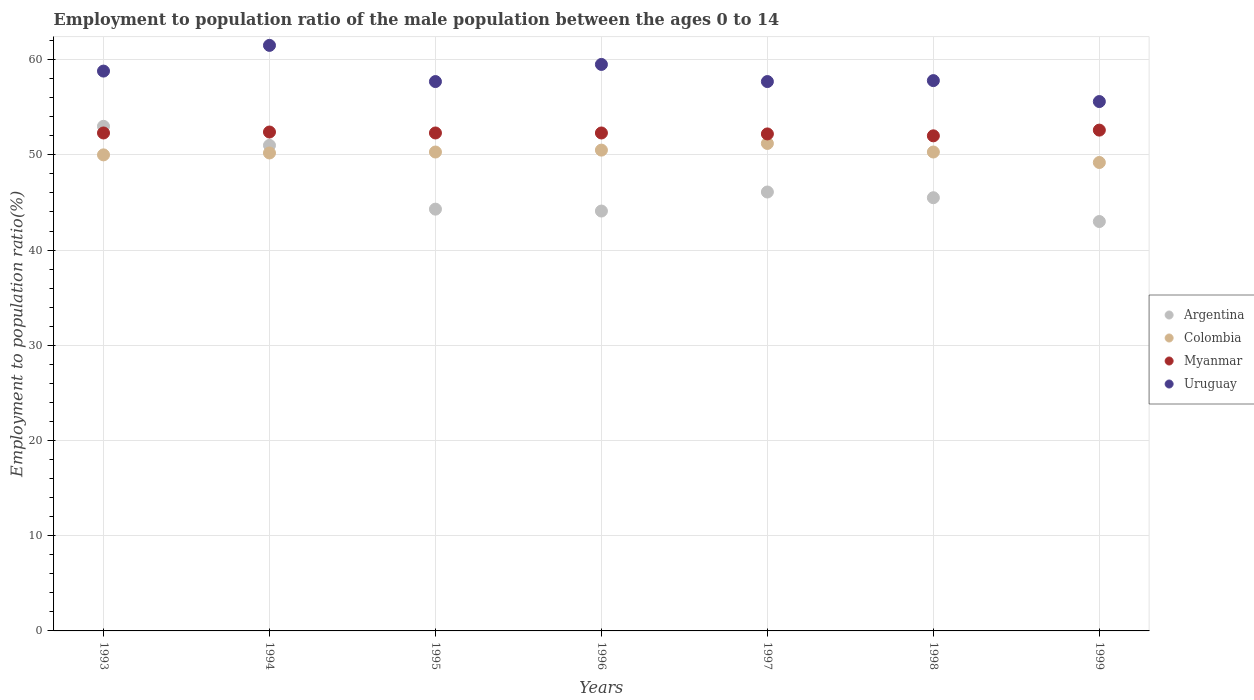What is the employment to population ratio in Colombia in 1996?
Your answer should be very brief. 50.5. Across all years, what is the maximum employment to population ratio in Colombia?
Give a very brief answer. 51.2. Across all years, what is the minimum employment to population ratio in Uruguay?
Ensure brevity in your answer.  55.6. In which year was the employment to population ratio in Uruguay maximum?
Provide a succinct answer. 1994. In which year was the employment to population ratio in Myanmar minimum?
Your answer should be very brief. 1998. What is the total employment to population ratio in Myanmar in the graph?
Your answer should be very brief. 366.1. What is the difference between the employment to population ratio in Argentina in 1996 and that in 1999?
Provide a short and direct response. 1.1. What is the difference between the employment to population ratio in Colombia in 1993 and the employment to population ratio in Argentina in 1997?
Your answer should be compact. 3.9. What is the average employment to population ratio in Argentina per year?
Offer a very short reply. 46.71. In the year 1998, what is the difference between the employment to population ratio in Argentina and employment to population ratio in Myanmar?
Provide a short and direct response. -6.5. What is the ratio of the employment to population ratio in Argentina in 1993 to that in 1997?
Your response must be concise. 1.15. What is the difference between the highest and the second highest employment to population ratio in Colombia?
Make the answer very short. 0.7. What is the difference between the highest and the lowest employment to population ratio in Uruguay?
Ensure brevity in your answer.  5.9. In how many years, is the employment to population ratio in Uruguay greater than the average employment to population ratio in Uruguay taken over all years?
Ensure brevity in your answer.  3. Is the sum of the employment to population ratio in Uruguay in 1994 and 1999 greater than the maximum employment to population ratio in Colombia across all years?
Offer a very short reply. Yes. Is it the case that in every year, the sum of the employment to population ratio in Myanmar and employment to population ratio in Colombia  is greater than the sum of employment to population ratio in Argentina and employment to population ratio in Uruguay?
Provide a short and direct response. No. Is the employment to population ratio in Uruguay strictly less than the employment to population ratio in Myanmar over the years?
Give a very brief answer. No. How many dotlines are there?
Your answer should be very brief. 4. How many years are there in the graph?
Give a very brief answer. 7. Are the values on the major ticks of Y-axis written in scientific E-notation?
Keep it short and to the point. No. Does the graph contain any zero values?
Your response must be concise. No. Does the graph contain grids?
Make the answer very short. Yes. How many legend labels are there?
Your response must be concise. 4. How are the legend labels stacked?
Make the answer very short. Vertical. What is the title of the graph?
Your response must be concise. Employment to population ratio of the male population between the ages 0 to 14. What is the label or title of the X-axis?
Your answer should be very brief. Years. What is the Employment to population ratio(%) in Myanmar in 1993?
Your answer should be very brief. 52.3. What is the Employment to population ratio(%) of Uruguay in 1993?
Make the answer very short. 58.8. What is the Employment to population ratio(%) in Argentina in 1994?
Your answer should be compact. 51. What is the Employment to population ratio(%) of Colombia in 1994?
Ensure brevity in your answer.  50.2. What is the Employment to population ratio(%) of Myanmar in 1994?
Offer a terse response. 52.4. What is the Employment to population ratio(%) of Uruguay in 1994?
Offer a terse response. 61.5. What is the Employment to population ratio(%) of Argentina in 1995?
Make the answer very short. 44.3. What is the Employment to population ratio(%) of Colombia in 1995?
Your answer should be compact. 50.3. What is the Employment to population ratio(%) in Myanmar in 1995?
Give a very brief answer. 52.3. What is the Employment to population ratio(%) of Uruguay in 1995?
Provide a succinct answer. 57.7. What is the Employment to population ratio(%) in Argentina in 1996?
Provide a succinct answer. 44.1. What is the Employment to population ratio(%) of Colombia in 1996?
Provide a succinct answer. 50.5. What is the Employment to population ratio(%) in Myanmar in 1996?
Your answer should be very brief. 52.3. What is the Employment to population ratio(%) in Uruguay in 1996?
Your response must be concise. 59.5. What is the Employment to population ratio(%) in Argentina in 1997?
Your answer should be compact. 46.1. What is the Employment to population ratio(%) in Colombia in 1997?
Provide a short and direct response. 51.2. What is the Employment to population ratio(%) of Myanmar in 1997?
Your response must be concise. 52.2. What is the Employment to population ratio(%) in Uruguay in 1997?
Ensure brevity in your answer.  57.7. What is the Employment to population ratio(%) of Argentina in 1998?
Your answer should be very brief. 45.5. What is the Employment to population ratio(%) of Colombia in 1998?
Offer a terse response. 50.3. What is the Employment to population ratio(%) of Myanmar in 1998?
Provide a succinct answer. 52. What is the Employment to population ratio(%) of Uruguay in 1998?
Your answer should be compact. 57.8. What is the Employment to population ratio(%) in Colombia in 1999?
Make the answer very short. 49.2. What is the Employment to population ratio(%) in Myanmar in 1999?
Offer a terse response. 52.6. What is the Employment to population ratio(%) of Uruguay in 1999?
Provide a short and direct response. 55.6. Across all years, what is the maximum Employment to population ratio(%) of Argentina?
Provide a short and direct response. 53. Across all years, what is the maximum Employment to population ratio(%) in Colombia?
Ensure brevity in your answer.  51.2. Across all years, what is the maximum Employment to population ratio(%) of Myanmar?
Your response must be concise. 52.6. Across all years, what is the maximum Employment to population ratio(%) of Uruguay?
Your response must be concise. 61.5. Across all years, what is the minimum Employment to population ratio(%) in Colombia?
Give a very brief answer. 49.2. Across all years, what is the minimum Employment to population ratio(%) of Uruguay?
Provide a succinct answer. 55.6. What is the total Employment to population ratio(%) in Argentina in the graph?
Provide a succinct answer. 327. What is the total Employment to population ratio(%) of Colombia in the graph?
Make the answer very short. 351.7. What is the total Employment to population ratio(%) of Myanmar in the graph?
Offer a terse response. 366.1. What is the total Employment to population ratio(%) of Uruguay in the graph?
Give a very brief answer. 408.6. What is the difference between the Employment to population ratio(%) in Argentina in 1993 and that in 1994?
Give a very brief answer. 2. What is the difference between the Employment to population ratio(%) of Colombia in 1993 and that in 1994?
Provide a succinct answer. -0.2. What is the difference between the Employment to population ratio(%) of Uruguay in 1993 and that in 1994?
Ensure brevity in your answer.  -2.7. What is the difference between the Employment to population ratio(%) in Colombia in 1993 and that in 1995?
Your answer should be very brief. -0.3. What is the difference between the Employment to population ratio(%) in Colombia in 1993 and that in 1996?
Keep it short and to the point. -0.5. What is the difference between the Employment to population ratio(%) in Myanmar in 1993 and that in 1996?
Offer a terse response. 0. What is the difference between the Employment to population ratio(%) in Argentina in 1993 and that in 1997?
Your answer should be compact. 6.9. What is the difference between the Employment to population ratio(%) in Colombia in 1993 and that in 1997?
Offer a terse response. -1.2. What is the difference between the Employment to population ratio(%) in Colombia in 1993 and that in 1998?
Offer a very short reply. -0.3. What is the difference between the Employment to population ratio(%) of Myanmar in 1993 and that in 1998?
Make the answer very short. 0.3. What is the difference between the Employment to population ratio(%) in Myanmar in 1993 and that in 1999?
Ensure brevity in your answer.  -0.3. What is the difference between the Employment to population ratio(%) in Uruguay in 1993 and that in 1999?
Your answer should be very brief. 3.2. What is the difference between the Employment to population ratio(%) of Argentina in 1994 and that in 1996?
Provide a short and direct response. 6.9. What is the difference between the Employment to population ratio(%) of Myanmar in 1994 and that in 1996?
Ensure brevity in your answer.  0.1. What is the difference between the Employment to population ratio(%) of Argentina in 1994 and that in 1997?
Your answer should be very brief. 4.9. What is the difference between the Employment to population ratio(%) in Colombia in 1994 and that in 1997?
Offer a terse response. -1. What is the difference between the Employment to population ratio(%) of Myanmar in 1994 and that in 1997?
Give a very brief answer. 0.2. What is the difference between the Employment to population ratio(%) in Argentina in 1994 and that in 1998?
Your answer should be very brief. 5.5. What is the difference between the Employment to population ratio(%) of Colombia in 1994 and that in 1998?
Make the answer very short. -0.1. What is the difference between the Employment to population ratio(%) of Myanmar in 1994 and that in 1998?
Ensure brevity in your answer.  0.4. What is the difference between the Employment to population ratio(%) of Uruguay in 1994 and that in 1998?
Provide a short and direct response. 3.7. What is the difference between the Employment to population ratio(%) in Colombia in 1995 and that in 1996?
Your response must be concise. -0.2. What is the difference between the Employment to population ratio(%) in Uruguay in 1995 and that in 1996?
Offer a very short reply. -1.8. What is the difference between the Employment to population ratio(%) in Argentina in 1995 and that in 1997?
Provide a succinct answer. -1.8. What is the difference between the Employment to population ratio(%) of Myanmar in 1995 and that in 1997?
Ensure brevity in your answer.  0.1. What is the difference between the Employment to population ratio(%) in Colombia in 1995 and that in 1998?
Your answer should be compact. 0. What is the difference between the Employment to population ratio(%) of Myanmar in 1995 and that in 1999?
Your answer should be very brief. -0.3. What is the difference between the Employment to population ratio(%) in Colombia in 1996 and that in 1997?
Provide a succinct answer. -0.7. What is the difference between the Employment to population ratio(%) in Uruguay in 1996 and that in 1997?
Keep it short and to the point. 1.8. What is the difference between the Employment to population ratio(%) in Colombia in 1996 and that in 1998?
Make the answer very short. 0.2. What is the difference between the Employment to population ratio(%) in Argentina in 1996 and that in 1999?
Your answer should be compact. 1.1. What is the difference between the Employment to population ratio(%) of Myanmar in 1996 and that in 1999?
Give a very brief answer. -0.3. What is the difference between the Employment to population ratio(%) of Uruguay in 1996 and that in 1999?
Provide a short and direct response. 3.9. What is the difference between the Employment to population ratio(%) of Colombia in 1997 and that in 1998?
Your answer should be very brief. 0.9. What is the difference between the Employment to population ratio(%) in Uruguay in 1997 and that in 1999?
Provide a short and direct response. 2.1. What is the difference between the Employment to population ratio(%) of Colombia in 1998 and that in 1999?
Your response must be concise. 1.1. What is the difference between the Employment to population ratio(%) in Argentina in 1993 and the Employment to population ratio(%) in Colombia in 1994?
Your answer should be compact. 2.8. What is the difference between the Employment to population ratio(%) in Argentina in 1993 and the Employment to population ratio(%) in Myanmar in 1994?
Your answer should be very brief. 0.6. What is the difference between the Employment to population ratio(%) of Argentina in 1993 and the Employment to population ratio(%) of Uruguay in 1994?
Provide a succinct answer. -8.5. What is the difference between the Employment to population ratio(%) in Argentina in 1993 and the Employment to population ratio(%) in Colombia in 1995?
Your answer should be very brief. 2.7. What is the difference between the Employment to population ratio(%) in Argentina in 1993 and the Employment to population ratio(%) in Myanmar in 1995?
Your response must be concise. 0.7. What is the difference between the Employment to population ratio(%) of Colombia in 1993 and the Employment to population ratio(%) of Uruguay in 1995?
Ensure brevity in your answer.  -7.7. What is the difference between the Employment to population ratio(%) of Myanmar in 1993 and the Employment to population ratio(%) of Uruguay in 1995?
Your answer should be compact. -5.4. What is the difference between the Employment to population ratio(%) of Argentina in 1993 and the Employment to population ratio(%) of Myanmar in 1996?
Your answer should be compact. 0.7. What is the difference between the Employment to population ratio(%) in Argentina in 1993 and the Employment to population ratio(%) in Uruguay in 1996?
Offer a very short reply. -6.5. What is the difference between the Employment to population ratio(%) of Colombia in 1993 and the Employment to population ratio(%) of Uruguay in 1996?
Your response must be concise. -9.5. What is the difference between the Employment to population ratio(%) of Argentina in 1993 and the Employment to population ratio(%) of Colombia in 1997?
Your response must be concise. 1.8. What is the difference between the Employment to population ratio(%) of Argentina in 1993 and the Employment to population ratio(%) of Uruguay in 1997?
Provide a succinct answer. -4.7. What is the difference between the Employment to population ratio(%) of Colombia in 1993 and the Employment to population ratio(%) of Myanmar in 1997?
Provide a succinct answer. -2.2. What is the difference between the Employment to population ratio(%) in Colombia in 1993 and the Employment to population ratio(%) in Uruguay in 1997?
Ensure brevity in your answer.  -7.7. What is the difference between the Employment to population ratio(%) in Argentina in 1993 and the Employment to population ratio(%) in Colombia in 1998?
Provide a short and direct response. 2.7. What is the difference between the Employment to population ratio(%) in Argentina in 1993 and the Employment to population ratio(%) in Myanmar in 1998?
Make the answer very short. 1. What is the difference between the Employment to population ratio(%) in Argentina in 1993 and the Employment to population ratio(%) in Uruguay in 1998?
Provide a succinct answer. -4.8. What is the difference between the Employment to population ratio(%) of Colombia in 1993 and the Employment to population ratio(%) of Uruguay in 1998?
Provide a succinct answer. -7.8. What is the difference between the Employment to population ratio(%) in Myanmar in 1993 and the Employment to population ratio(%) in Uruguay in 1998?
Your response must be concise. -5.5. What is the difference between the Employment to population ratio(%) of Argentina in 1993 and the Employment to population ratio(%) of Uruguay in 1999?
Provide a short and direct response. -2.6. What is the difference between the Employment to population ratio(%) in Argentina in 1994 and the Employment to population ratio(%) in Uruguay in 1995?
Offer a terse response. -6.7. What is the difference between the Employment to population ratio(%) of Colombia in 1994 and the Employment to population ratio(%) of Myanmar in 1995?
Ensure brevity in your answer.  -2.1. What is the difference between the Employment to population ratio(%) of Colombia in 1994 and the Employment to population ratio(%) of Myanmar in 1996?
Make the answer very short. -2.1. What is the difference between the Employment to population ratio(%) of Colombia in 1994 and the Employment to population ratio(%) of Uruguay in 1996?
Your answer should be compact. -9.3. What is the difference between the Employment to population ratio(%) of Myanmar in 1994 and the Employment to population ratio(%) of Uruguay in 1996?
Offer a terse response. -7.1. What is the difference between the Employment to population ratio(%) in Argentina in 1994 and the Employment to population ratio(%) in Colombia in 1997?
Give a very brief answer. -0.2. What is the difference between the Employment to population ratio(%) in Colombia in 1994 and the Employment to population ratio(%) in Myanmar in 1997?
Give a very brief answer. -2. What is the difference between the Employment to population ratio(%) in Colombia in 1994 and the Employment to population ratio(%) in Uruguay in 1997?
Offer a terse response. -7.5. What is the difference between the Employment to population ratio(%) of Myanmar in 1994 and the Employment to population ratio(%) of Uruguay in 1997?
Make the answer very short. -5.3. What is the difference between the Employment to population ratio(%) of Argentina in 1994 and the Employment to population ratio(%) of Colombia in 1998?
Your response must be concise. 0.7. What is the difference between the Employment to population ratio(%) of Argentina in 1994 and the Employment to population ratio(%) of Myanmar in 1998?
Provide a succinct answer. -1. What is the difference between the Employment to population ratio(%) in Colombia in 1994 and the Employment to population ratio(%) in Myanmar in 1998?
Give a very brief answer. -1.8. What is the difference between the Employment to population ratio(%) in Colombia in 1994 and the Employment to population ratio(%) in Uruguay in 1998?
Offer a very short reply. -7.6. What is the difference between the Employment to population ratio(%) in Myanmar in 1994 and the Employment to population ratio(%) in Uruguay in 1998?
Offer a very short reply. -5.4. What is the difference between the Employment to population ratio(%) of Argentina in 1994 and the Employment to population ratio(%) of Myanmar in 1999?
Your answer should be compact. -1.6. What is the difference between the Employment to population ratio(%) in Myanmar in 1994 and the Employment to population ratio(%) in Uruguay in 1999?
Offer a very short reply. -3.2. What is the difference between the Employment to population ratio(%) of Argentina in 1995 and the Employment to population ratio(%) of Uruguay in 1996?
Keep it short and to the point. -15.2. What is the difference between the Employment to population ratio(%) of Colombia in 1995 and the Employment to population ratio(%) of Myanmar in 1996?
Offer a terse response. -2. What is the difference between the Employment to population ratio(%) of Colombia in 1995 and the Employment to population ratio(%) of Uruguay in 1996?
Offer a very short reply. -9.2. What is the difference between the Employment to population ratio(%) of Myanmar in 1995 and the Employment to population ratio(%) of Uruguay in 1996?
Provide a succinct answer. -7.2. What is the difference between the Employment to population ratio(%) of Argentina in 1995 and the Employment to population ratio(%) of Uruguay in 1997?
Ensure brevity in your answer.  -13.4. What is the difference between the Employment to population ratio(%) in Colombia in 1995 and the Employment to population ratio(%) in Myanmar in 1997?
Offer a very short reply. -1.9. What is the difference between the Employment to population ratio(%) of Colombia in 1995 and the Employment to population ratio(%) of Uruguay in 1997?
Keep it short and to the point. -7.4. What is the difference between the Employment to population ratio(%) of Myanmar in 1995 and the Employment to population ratio(%) of Uruguay in 1997?
Your answer should be very brief. -5.4. What is the difference between the Employment to population ratio(%) in Argentina in 1995 and the Employment to population ratio(%) in Colombia in 1998?
Provide a short and direct response. -6. What is the difference between the Employment to population ratio(%) in Colombia in 1995 and the Employment to population ratio(%) in Myanmar in 1998?
Your answer should be compact. -1.7. What is the difference between the Employment to population ratio(%) of Colombia in 1995 and the Employment to population ratio(%) of Uruguay in 1998?
Offer a very short reply. -7.5. What is the difference between the Employment to population ratio(%) in Myanmar in 1995 and the Employment to population ratio(%) in Uruguay in 1998?
Provide a succinct answer. -5.5. What is the difference between the Employment to population ratio(%) in Argentina in 1995 and the Employment to population ratio(%) in Uruguay in 1999?
Offer a terse response. -11.3. What is the difference between the Employment to population ratio(%) of Colombia in 1995 and the Employment to population ratio(%) of Myanmar in 1999?
Ensure brevity in your answer.  -2.3. What is the difference between the Employment to population ratio(%) of Colombia in 1995 and the Employment to population ratio(%) of Uruguay in 1999?
Provide a succinct answer. -5.3. What is the difference between the Employment to population ratio(%) of Argentina in 1996 and the Employment to population ratio(%) of Colombia in 1997?
Your response must be concise. -7.1. What is the difference between the Employment to population ratio(%) of Argentina in 1996 and the Employment to population ratio(%) of Uruguay in 1997?
Your answer should be compact. -13.6. What is the difference between the Employment to population ratio(%) in Colombia in 1996 and the Employment to population ratio(%) in Myanmar in 1997?
Your answer should be very brief. -1.7. What is the difference between the Employment to population ratio(%) in Colombia in 1996 and the Employment to population ratio(%) in Uruguay in 1997?
Offer a very short reply. -7.2. What is the difference between the Employment to population ratio(%) of Myanmar in 1996 and the Employment to population ratio(%) of Uruguay in 1997?
Your response must be concise. -5.4. What is the difference between the Employment to population ratio(%) in Argentina in 1996 and the Employment to population ratio(%) in Myanmar in 1998?
Keep it short and to the point. -7.9. What is the difference between the Employment to population ratio(%) of Argentina in 1996 and the Employment to population ratio(%) of Uruguay in 1998?
Your response must be concise. -13.7. What is the difference between the Employment to population ratio(%) of Colombia in 1996 and the Employment to population ratio(%) of Uruguay in 1998?
Your response must be concise. -7.3. What is the difference between the Employment to population ratio(%) in Myanmar in 1996 and the Employment to population ratio(%) in Uruguay in 1998?
Your response must be concise. -5.5. What is the difference between the Employment to population ratio(%) of Argentina in 1996 and the Employment to population ratio(%) of Colombia in 1999?
Offer a terse response. -5.1. What is the difference between the Employment to population ratio(%) of Argentina in 1996 and the Employment to population ratio(%) of Myanmar in 1999?
Provide a short and direct response. -8.5. What is the difference between the Employment to population ratio(%) in Colombia in 1996 and the Employment to population ratio(%) in Uruguay in 1999?
Make the answer very short. -5.1. What is the difference between the Employment to population ratio(%) of Argentina in 1997 and the Employment to population ratio(%) of Colombia in 1998?
Keep it short and to the point. -4.2. What is the difference between the Employment to population ratio(%) of Argentina in 1997 and the Employment to population ratio(%) of Myanmar in 1998?
Keep it short and to the point. -5.9. What is the difference between the Employment to population ratio(%) in Colombia in 1997 and the Employment to population ratio(%) in Uruguay in 1998?
Provide a succinct answer. -6.6. What is the difference between the Employment to population ratio(%) in Argentina in 1997 and the Employment to population ratio(%) in Colombia in 1999?
Ensure brevity in your answer.  -3.1. What is the difference between the Employment to population ratio(%) of Argentina in 1997 and the Employment to population ratio(%) of Uruguay in 1999?
Your answer should be compact. -9.5. What is the difference between the Employment to population ratio(%) in Myanmar in 1997 and the Employment to population ratio(%) in Uruguay in 1999?
Offer a terse response. -3.4. What is the difference between the Employment to population ratio(%) of Colombia in 1998 and the Employment to population ratio(%) of Myanmar in 1999?
Give a very brief answer. -2.3. What is the average Employment to population ratio(%) of Argentina per year?
Your answer should be very brief. 46.71. What is the average Employment to population ratio(%) of Colombia per year?
Your answer should be compact. 50.24. What is the average Employment to population ratio(%) in Myanmar per year?
Give a very brief answer. 52.3. What is the average Employment to population ratio(%) of Uruguay per year?
Offer a very short reply. 58.37. In the year 1993, what is the difference between the Employment to population ratio(%) in Argentina and Employment to population ratio(%) in Colombia?
Your response must be concise. 3. In the year 1993, what is the difference between the Employment to population ratio(%) of Colombia and Employment to population ratio(%) of Myanmar?
Provide a short and direct response. -2.3. In the year 1993, what is the difference between the Employment to population ratio(%) in Myanmar and Employment to population ratio(%) in Uruguay?
Provide a succinct answer. -6.5. In the year 1994, what is the difference between the Employment to population ratio(%) in Colombia and Employment to population ratio(%) in Myanmar?
Give a very brief answer. -2.2. In the year 1994, what is the difference between the Employment to population ratio(%) of Myanmar and Employment to population ratio(%) of Uruguay?
Give a very brief answer. -9.1. In the year 1995, what is the difference between the Employment to population ratio(%) in Argentina and Employment to population ratio(%) in Colombia?
Your answer should be very brief. -6. In the year 1995, what is the difference between the Employment to population ratio(%) of Argentina and Employment to population ratio(%) of Myanmar?
Provide a short and direct response. -8. In the year 1995, what is the difference between the Employment to population ratio(%) of Myanmar and Employment to population ratio(%) of Uruguay?
Provide a succinct answer. -5.4. In the year 1996, what is the difference between the Employment to population ratio(%) of Argentina and Employment to population ratio(%) of Colombia?
Offer a very short reply. -6.4. In the year 1996, what is the difference between the Employment to population ratio(%) in Argentina and Employment to population ratio(%) in Uruguay?
Your response must be concise. -15.4. In the year 1996, what is the difference between the Employment to population ratio(%) in Colombia and Employment to population ratio(%) in Uruguay?
Provide a short and direct response. -9. In the year 1996, what is the difference between the Employment to population ratio(%) in Myanmar and Employment to population ratio(%) in Uruguay?
Make the answer very short. -7.2. In the year 1997, what is the difference between the Employment to population ratio(%) of Argentina and Employment to population ratio(%) of Myanmar?
Ensure brevity in your answer.  -6.1. In the year 1997, what is the difference between the Employment to population ratio(%) in Argentina and Employment to population ratio(%) in Uruguay?
Your answer should be compact. -11.6. In the year 1997, what is the difference between the Employment to population ratio(%) in Myanmar and Employment to population ratio(%) in Uruguay?
Make the answer very short. -5.5. In the year 1998, what is the difference between the Employment to population ratio(%) in Colombia and Employment to population ratio(%) in Myanmar?
Make the answer very short. -1.7. In the year 1998, what is the difference between the Employment to population ratio(%) in Colombia and Employment to population ratio(%) in Uruguay?
Ensure brevity in your answer.  -7.5. In the year 1999, what is the difference between the Employment to population ratio(%) of Argentina and Employment to population ratio(%) of Colombia?
Ensure brevity in your answer.  -6.2. In the year 1999, what is the difference between the Employment to population ratio(%) of Argentina and Employment to population ratio(%) of Myanmar?
Your response must be concise. -9.6. In the year 1999, what is the difference between the Employment to population ratio(%) in Colombia and Employment to population ratio(%) in Myanmar?
Offer a terse response. -3.4. In the year 1999, what is the difference between the Employment to population ratio(%) of Colombia and Employment to population ratio(%) of Uruguay?
Provide a short and direct response. -6.4. What is the ratio of the Employment to population ratio(%) of Argentina in 1993 to that in 1994?
Your answer should be compact. 1.04. What is the ratio of the Employment to population ratio(%) of Myanmar in 1993 to that in 1994?
Provide a short and direct response. 1. What is the ratio of the Employment to population ratio(%) in Uruguay in 1993 to that in 1994?
Your answer should be very brief. 0.96. What is the ratio of the Employment to population ratio(%) in Argentina in 1993 to that in 1995?
Provide a short and direct response. 1.2. What is the ratio of the Employment to population ratio(%) of Colombia in 1993 to that in 1995?
Offer a very short reply. 0.99. What is the ratio of the Employment to population ratio(%) in Uruguay in 1993 to that in 1995?
Offer a terse response. 1.02. What is the ratio of the Employment to population ratio(%) of Argentina in 1993 to that in 1996?
Give a very brief answer. 1.2. What is the ratio of the Employment to population ratio(%) in Argentina in 1993 to that in 1997?
Give a very brief answer. 1.15. What is the ratio of the Employment to population ratio(%) of Colombia in 1993 to that in 1997?
Your answer should be very brief. 0.98. What is the ratio of the Employment to population ratio(%) in Myanmar in 1993 to that in 1997?
Offer a very short reply. 1. What is the ratio of the Employment to population ratio(%) in Uruguay in 1993 to that in 1997?
Make the answer very short. 1.02. What is the ratio of the Employment to population ratio(%) in Argentina in 1993 to that in 1998?
Provide a short and direct response. 1.16. What is the ratio of the Employment to population ratio(%) of Uruguay in 1993 to that in 1998?
Your answer should be compact. 1.02. What is the ratio of the Employment to population ratio(%) of Argentina in 1993 to that in 1999?
Give a very brief answer. 1.23. What is the ratio of the Employment to population ratio(%) of Colombia in 1993 to that in 1999?
Offer a terse response. 1.02. What is the ratio of the Employment to population ratio(%) in Myanmar in 1993 to that in 1999?
Ensure brevity in your answer.  0.99. What is the ratio of the Employment to population ratio(%) of Uruguay in 1993 to that in 1999?
Your response must be concise. 1.06. What is the ratio of the Employment to population ratio(%) of Argentina in 1994 to that in 1995?
Your answer should be compact. 1.15. What is the ratio of the Employment to population ratio(%) of Uruguay in 1994 to that in 1995?
Make the answer very short. 1.07. What is the ratio of the Employment to population ratio(%) in Argentina in 1994 to that in 1996?
Offer a very short reply. 1.16. What is the ratio of the Employment to population ratio(%) of Colombia in 1994 to that in 1996?
Offer a terse response. 0.99. What is the ratio of the Employment to population ratio(%) of Uruguay in 1994 to that in 1996?
Provide a succinct answer. 1.03. What is the ratio of the Employment to population ratio(%) in Argentina in 1994 to that in 1997?
Ensure brevity in your answer.  1.11. What is the ratio of the Employment to population ratio(%) in Colombia in 1994 to that in 1997?
Your answer should be compact. 0.98. What is the ratio of the Employment to population ratio(%) of Myanmar in 1994 to that in 1997?
Provide a succinct answer. 1. What is the ratio of the Employment to population ratio(%) in Uruguay in 1994 to that in 1997?
Provide a succinct answer. 1.07. What is the ratio of the Employment to population ratio(%) of Argentina in 1994 to that in 1998?
Provide a short and direct response. 1.12. What is the ratio of the Employment to population ratio(%) of Colombia in 1994 to that in 1998?
Your answer should be very brief. 1. What is the ratio of the Employment to population ratio(%) of Myanmar in 1994 to that in 1998?
Your response must be concise. 1.01. What is the ratio of the Employment to population ratio(%) in Uruguay in 1994 to that in 1998?
Your answer should be very brief. 1.06. What is the ratio of the Employment to population ratio(%) of Argentina in 1994 to that in 1999?
Your answer should be compact. 1.19. What is the ratio of the Employment to population ratio(%) in Colombia in 1994 to that in 1999?
Offer a terse response. 1.02. What is the ratio of the Employment to population ratio(%) of Uruguay in 1994 to that in 1999?
Your answer should be compact. 1.11. What is the ratio of the Employment to population ratio(%) of Colombia in 1995 to that in 1996?
Your answer should be very brief. 1. What is the ratio of the Employment to population ratio(%) in Uruguay in 1995 to that in 1996?
Provide a short and direct response. 0.97. What is the ratio of the Employment to population ratio(%) in Argentina in 1995 to that in 1997?
Give a very brief answer. 0.96. What is the ratio of the Employment to population ratio(%) in Colombia in 1995 to that in 1997?
Make the answer very short. 0.98. What is the ratio of the Employment to population ratio(%) in Myanmar in 1995 to that in 1997?
Give a very brief answer. 1. What is the ratio of the Employment to population ratio(%) of Argentina in 1995 to that in 1998?
Provide a short and direct response. 0.97. What is the ratio of the Employment to population ratio(%) in Myanmar in 1995 to that in 1998?
Ensure brevity in your answer.  1.01. What is the ratio of the Employment to population ratio(%) in Argentina in 1995 to that in 1999?
Offer a very short reply. 1.03. What is the ratio of the Employment to population ratio(%) in Colombia in 1995 to that in 1999?
Offer a terse response. 1.02. What is the ratio of the Employment to population ratio(%) of Myanmar in 1995 to that in 1999?
Your answer should be very brief. 0.99. What is the ratio of the Employment to population ratio(%) in Uruguay in 1995 to that in 1999?
Your response must be concise. 1.04. What is the ratio of the Employment to population ratio(%) of Argentina in 1996 to that in 1997?
Your response must be concise. 0.96. What is the ratio of the Employment to population ratio(%) in Colombia in 1996 to that in 1997?
Provide a short and direct response. 0.99. What is the ratio of the Employment to population ratio(%) in Myanmar in 1996 to that in 1997?
Give a very brief answer. 1. What is the ratio of the Employment to population ratio(%) of Uruguay in 1996 to that in 1997?
Your response must be concise. 1.03. What is the ratio of the Employment to population ratio(%) of Argentina in 1996 to that in 1998?
Keep it short and to the point. 0.97. What is the ratio of the Employment to population ratio(%) in Uruguay in 1996 to that in 1998?
Make the answer very short. 1.03. What is the ratio of the Employment to population ratio(%) in Argentina in 1996 to that in 1999?
Make the answer very short. 1.03. What is the ratio of the Employment to population ratio(%) in Colombia in 1996 to that in 1999?
Provide a succinct answer. 1.03. What is the ratio of the Employment to population ratio(%) in Myanmar in 1996 to that in 1999?
Your response must be concise. 0.99. What is the ratio of the Employment to population ratio(%) in Uruguay in 1996 to that in 1999?
Your response must be concise. 1.07. What is the ratio of the Employment to population ratio(%) of Argentina in 1997 to that in 1998?
Keep it short and to the point. 1.01. What is the ratio of the Employment to population ratio(%) in Colombia in 1997 to that in 1998?
Your answer should be compact. 1.02. What is the ratio of the Employment to population ratio(%) in Myanmar in 1997 to that in 1998?
Give a very brief answer. 1. What is the ratio of the Employment to population ratio(%) of Argentina in 1997 to that in 1999?
Offer a terse response. 1.07. What is the ratio of the Employment to population ratio(%) of Colombia in 1997 to that in 1999?
Your answer should be compact. 1.04. What is the ratio of the Employment to population ratio(%) in Uruguay in 1997 to that in 1999?
Your response must be concise. 1.04. What is the ratio of the Employment to population ratio(%) of Argentina in 1998 to that in 1999?
Your response must be concise. 1.06. What is the ratio of the Employment to population ratio(%) of Colombia in 1998 to that in 1999?
Keep it short and to the point. 1.02. What is the ratio of the Employment to population ratio(%) of Myanmar in 1998 to that in 1999?
Your response must be concise. 0.99. What is the ratio of the Employment to population ratio(%) in Uruguay in 1998 to that in 1999?
Provide a short and direct response. 1.04. What is the difference between the highest and the second highest Employment to population ratio(%) in Colombia?
Provide a succinct answer. 0.7. What is the difference between the highest and the second highest Employment to population ratio(%) of Uruguay?
Provide a short and direct response. 2. What is the difference between the highest and the lowest Employment to population ratio(%) of Argentina?
Make the answer very short. 10. What is the difference between the highest and the lowest Employment to population ratio(%) in Myanmar?
Offer a terse response. 0.6. What is the difference between the highest and the lowest Employment to population ratio(%) of Uruguay?
Make the answer very short. 5.9. 